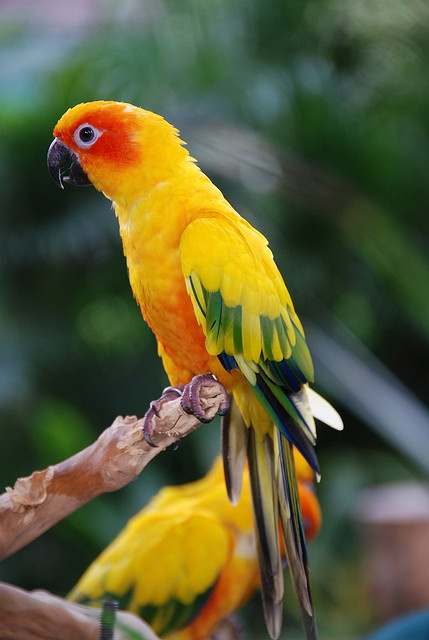Describe the objects in this image and their specific colors. I can see bird in gray, orange, gold, black, and olive tones and bird in gray, orange, olive, and black tones in this image. 